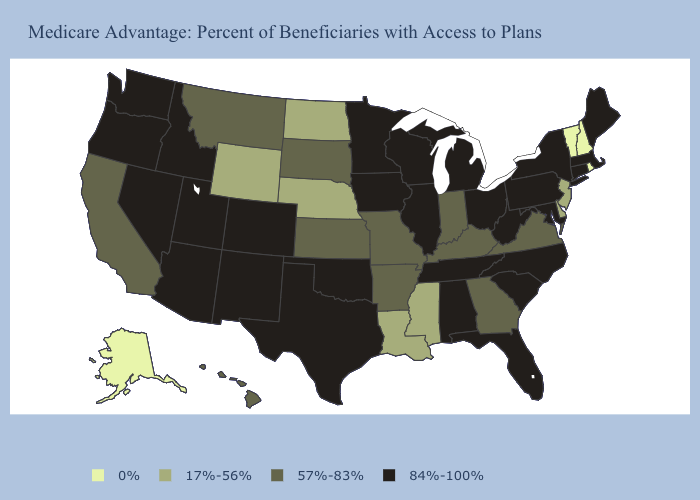What is the lowest value in states that border Missouri?
Keep it brief. 17%-56%. Does Nevada have a lower value than Oregon?
Keep it brief. No. Does Oregon have the lowest value in the West?
Give a very brief answer. No. What is the value of New Jersey?
Be succinct. 17%-56%. Among the states that border Rhode Island , which have the highest value?
Short answer required. Connecticut, Massachusetts. Does Minnesota have the highest value in the USA?
Answer briefly. Yes. What is the highest value in the West ?
Write a very short answer. 84%-100%. Which states hav the highest value in the West?
Keep it brief. Arizona, Colorado, Idaho, New Mexico, Nevada, Oregon, Utah, Washington. What is the value of Iowa?
Concise answer only. 84%-100%. Name the states that have a value in the range 84%-100%?
Give a very brief answer. Alabama, Arizona, Colorado, Connecticut, Florida, Iowa, Idaho, Illinois, Massachusetts, Maryland, Maine, Michigan, Minnesota, North Carolina, New Mexico, Nevada, New York, Ohio, Oklahoma, Oregon, Pennsylvania, South Carolina, Tennessee, Texas, Utah, Washington, Wisconsin, West Virginia. Which states have the highest value in the USA?
Give a very brief answer. Alabama, Arizona, Colorado, Connecticut, Florida, Iowa, Idaho, Illinois, Massachusetts, Maryland, Maine, Michigan, Minnesota, North Carolina, New Mexico, Nevada, New York, Ohio, Oklahoma, Oregon, Pennsylvania, South Carolina, Tennessee, Texas, Utah, Washington, Wisconsin, West Virginia. Does Washington have the lowest value in the USA?
Quick response, please. No. What is the highest value in states that border West Virginia?
Keep it brief. 84%-100%. Which states have the lowest value in the West?
Write a very short answer. Alaska. What is the value of Hawaii?
Write a very short answer. 57%-83%. 